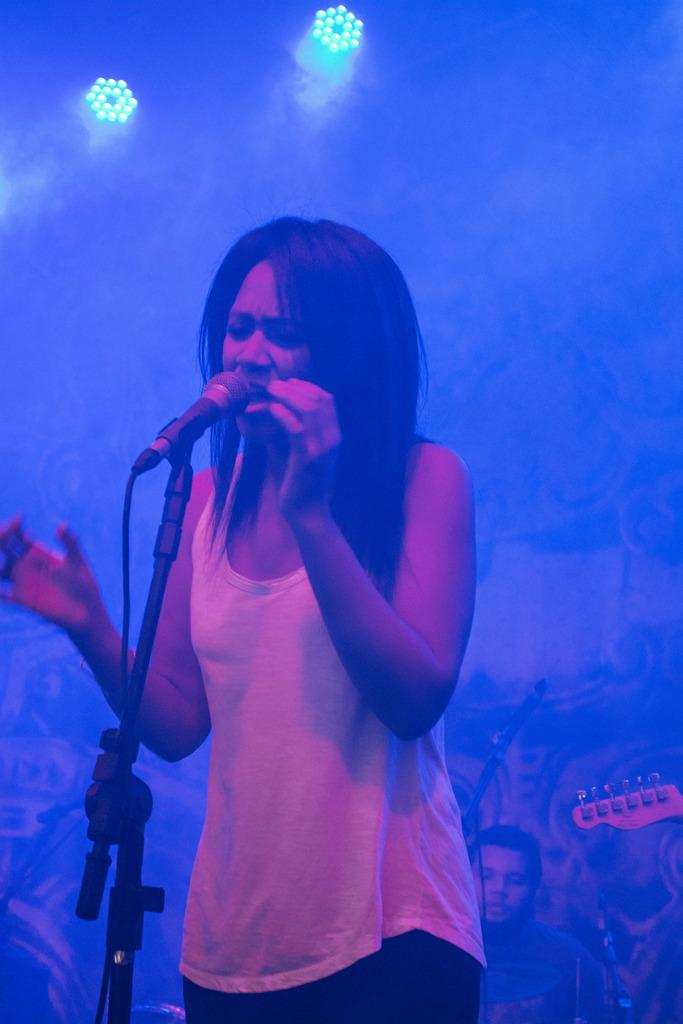What is the person in the image doing? The person is standing and singing. What is the person using to amplify their voice? There is a microphone in front of the person. What is the microphone attached to? There is a microphone stand in front of the person. Can you describe the people behind the person? There are other people behind the person. What can be seen on top in the image? There are lights on the top. What type of bird is flying over the person's head in the image? There is no bird present in the image. How does the person's anger affect their singing performance in the image? The person's anger is not mentioned in the image, and therefore it cannot be determined how it affects their singing performance. 